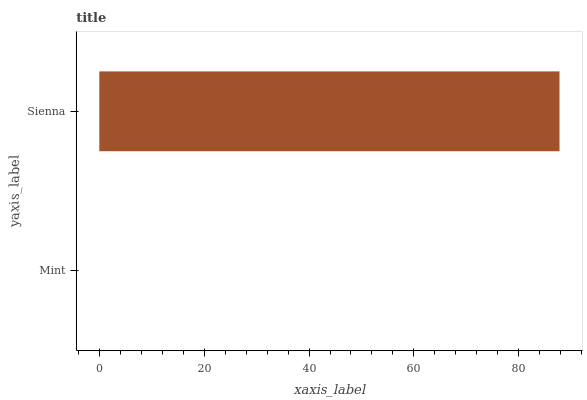Is Mint the minimum?
Answer yes or no. Yes. Is Sienna the maximum?
Answer yes or no. Yes. Is Sienna the minimum?
Answer yes or no. No. Is Sienna greater than Mint?
Answer yes or no. Yes. Is Mint less than Sienna?
Answer yes or no. Yes. Is Mint greater than Sienna?
Answer yes or no. No. Is Sienna less than Mint?
Answer yes or no. No. Is Sienna the high median?
Answer yes or no. Yes. Is Mint the low median?
Answer yes or no. Yes. Is Mint the high median?
Answer yes or no. No. Is Sienna the low median?
Answer yes or no. No. 